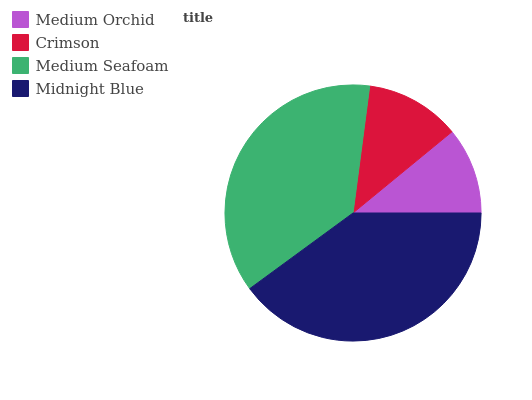Is Medium Orchid the minimum?
Answer yes or no. Yes. Is Midnight Blue the maximum?
Answer yes or no. Yes. Is Crimson the minimum?
Answer yes or no. No. Is Crimson the maximum?
Answer yes or no. No. Is Crimson greater than Medium Orchid?
Answer yes or no. Yes. Is Medium Orchid less than Crimson?
Answer yes or no. Yes. Is Medium Orchid greater than Crimson?
Answer yes or no. No. Is Crimson less than Medium Orchid?
Answer yes or no. No. Is Medium Seafoam the high median?
Answer yes or no. Yes. Is Crimson the low median?
Answer yes or no. Yes. Is Crimson the high median?
Answer yes or no. No. Is Midnight Blue the low median?
Answer yes or no. No. 